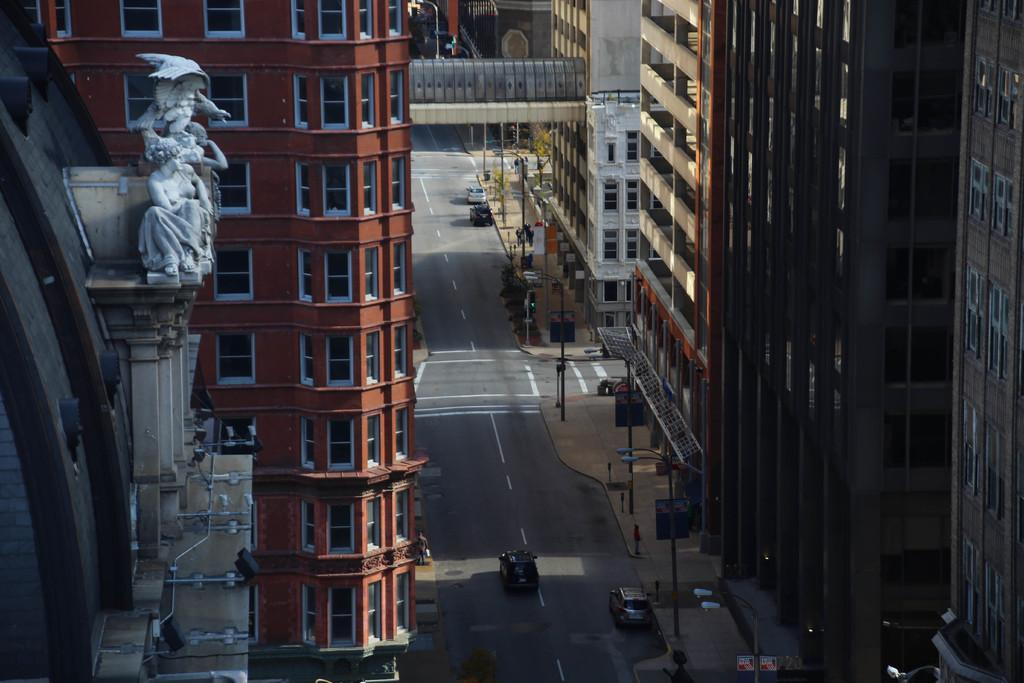What can be seen at the bottom of the image? There are fleets of cars at the bottom of the image. What is present along the road in the image? There are light poles on the road. What is visible in the foreground of the image? In the foreground, there are buildings, statues, a bridge, and trees. Can you describe the time of day when the image was taken? The image is likely taken during the day, as there is sufficient light to see the details clearly. Can you see any spoons flying in the image? There are no spoons present in the image, let alone any that are flying. 